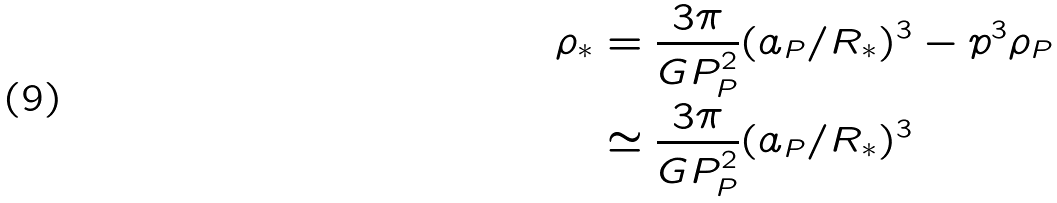<formula> <loc_0><loc_0><loc_500><loc_500>\rho _ { * } & = \frac { 3 \pi } { G P _ { P } ^ { 2 } } ( a _ { P } / R _ { * } ) ^ { 3 } - p ^ { 3 } \rho _ { P } \\ \quad & \simeq \frac { 3 \pi } { G P _ { P } ^ { 2 } } ( a _ { P } / R _ { * } ) ^ { 3 }</formula> 